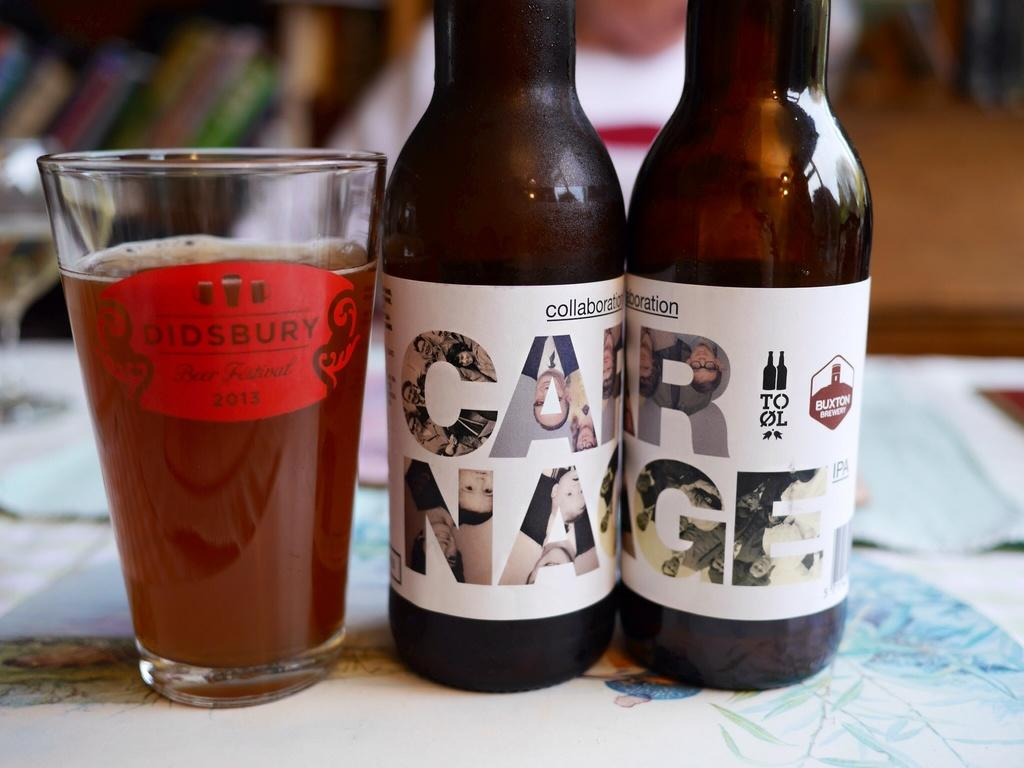<image>
Create a compact narrative representing the image presented. a didsbury glass  lined up with two ottles of car nage beer 